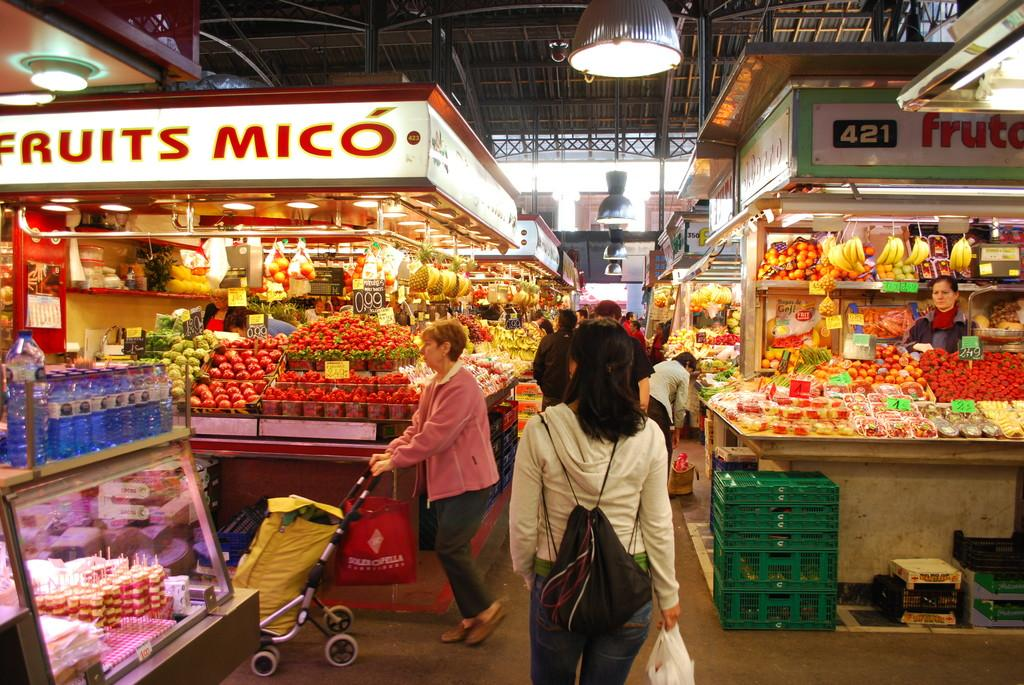<image>
Summarize the visual content of the image. A fruits Mico lighted sign is above various fruits and vegetables. 